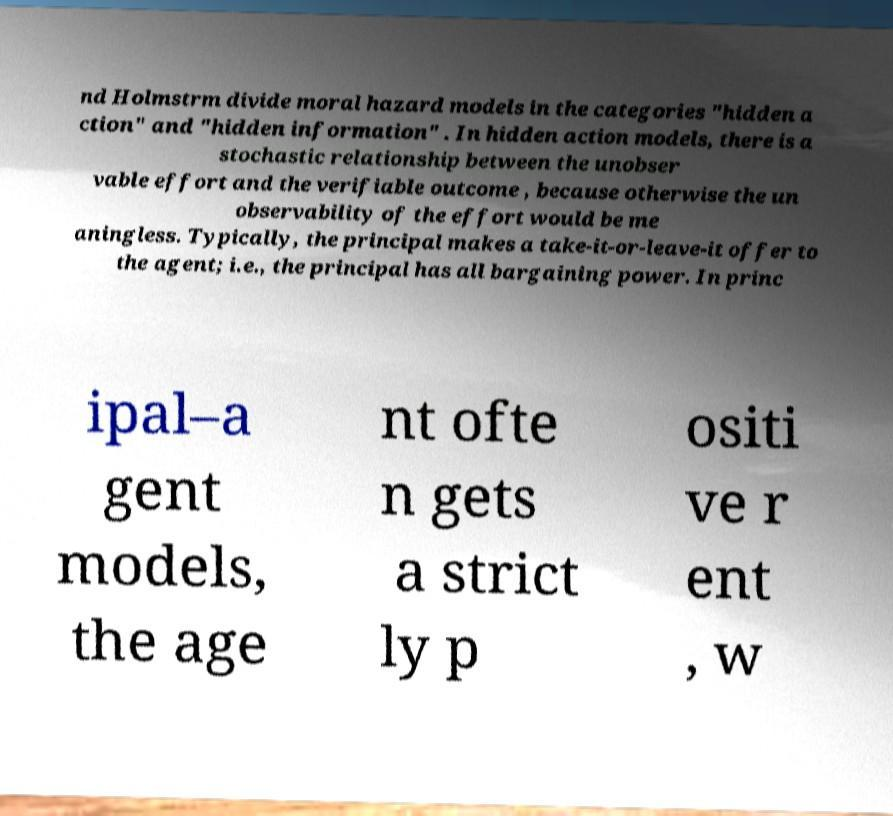There's text embedded in this image that I need extracted. Can you transcribe it verbatim? nd Holmstrm divide moral hazard models in the categories "hidden a ction" and "hidden information" . In hidden action models, there is a stochastic relationship between the unobser vable effort and the verifiable outcome , because otherwise the un observability of the effort would be me aningless. Typically, the principal makes a take-it-or-leave-it offer to the agent; i.e., the principal has all bargaining power. In princ ipal–a gent models, the age nt ofte n gets a strict ly p ositi ve r ent , w 